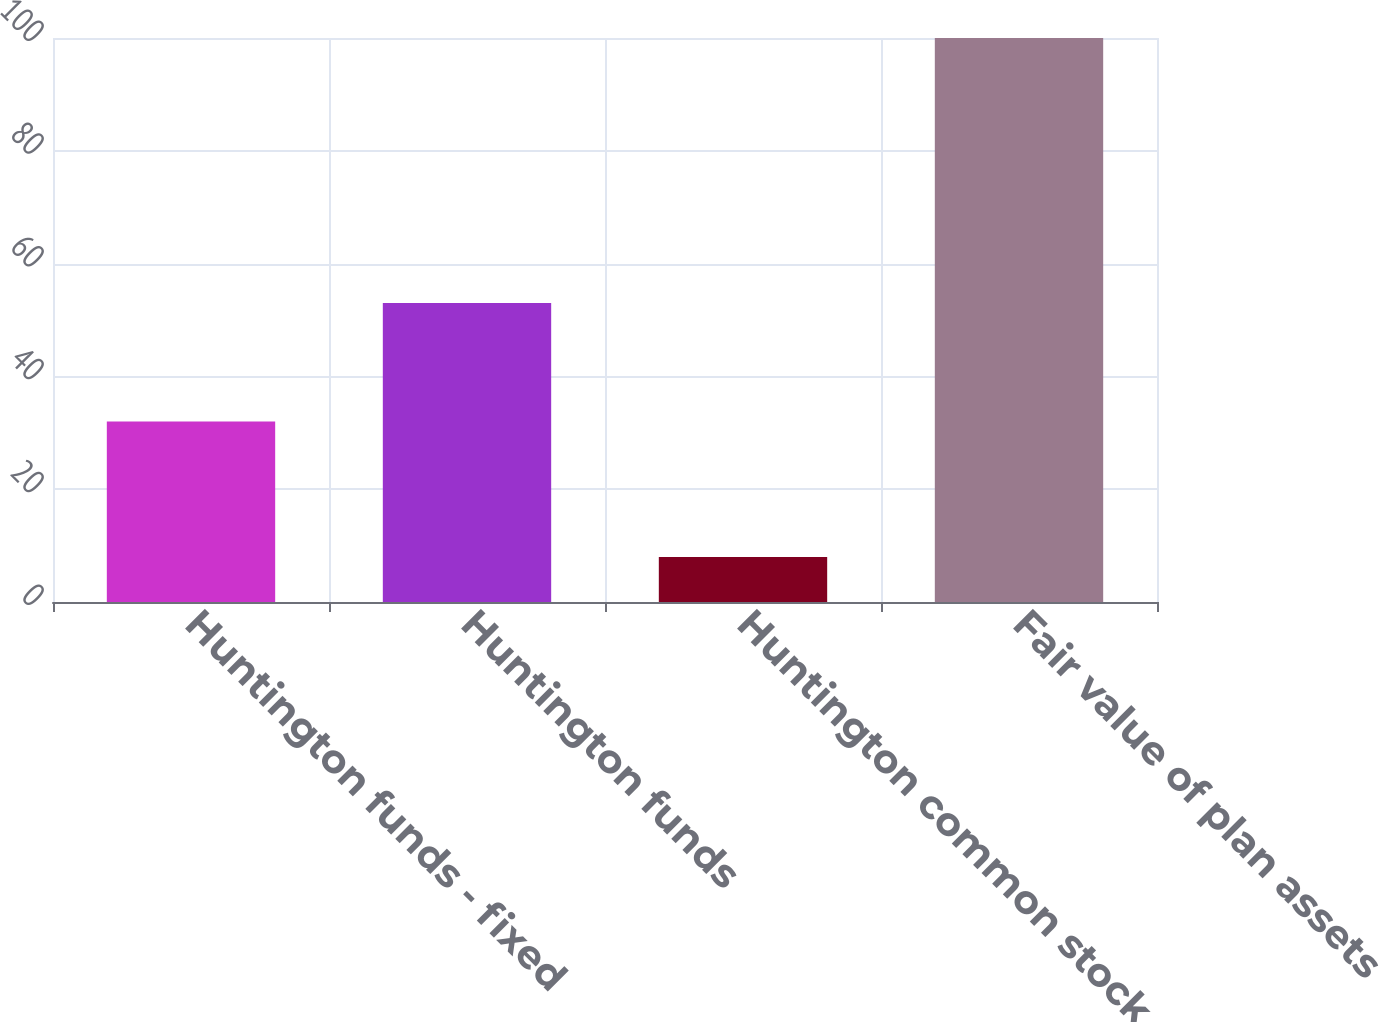<chart> <loc_0><loc_0><loc_500><loc_500><bar_chart><fcel>Huntington funds - fixed<fcel>Huntington funds<fcel>Huntington common stock<fcel>Fair value of plan assets<nl><fcel>32<fcel>53<fcel>8<fcel>100<nl></chart> 